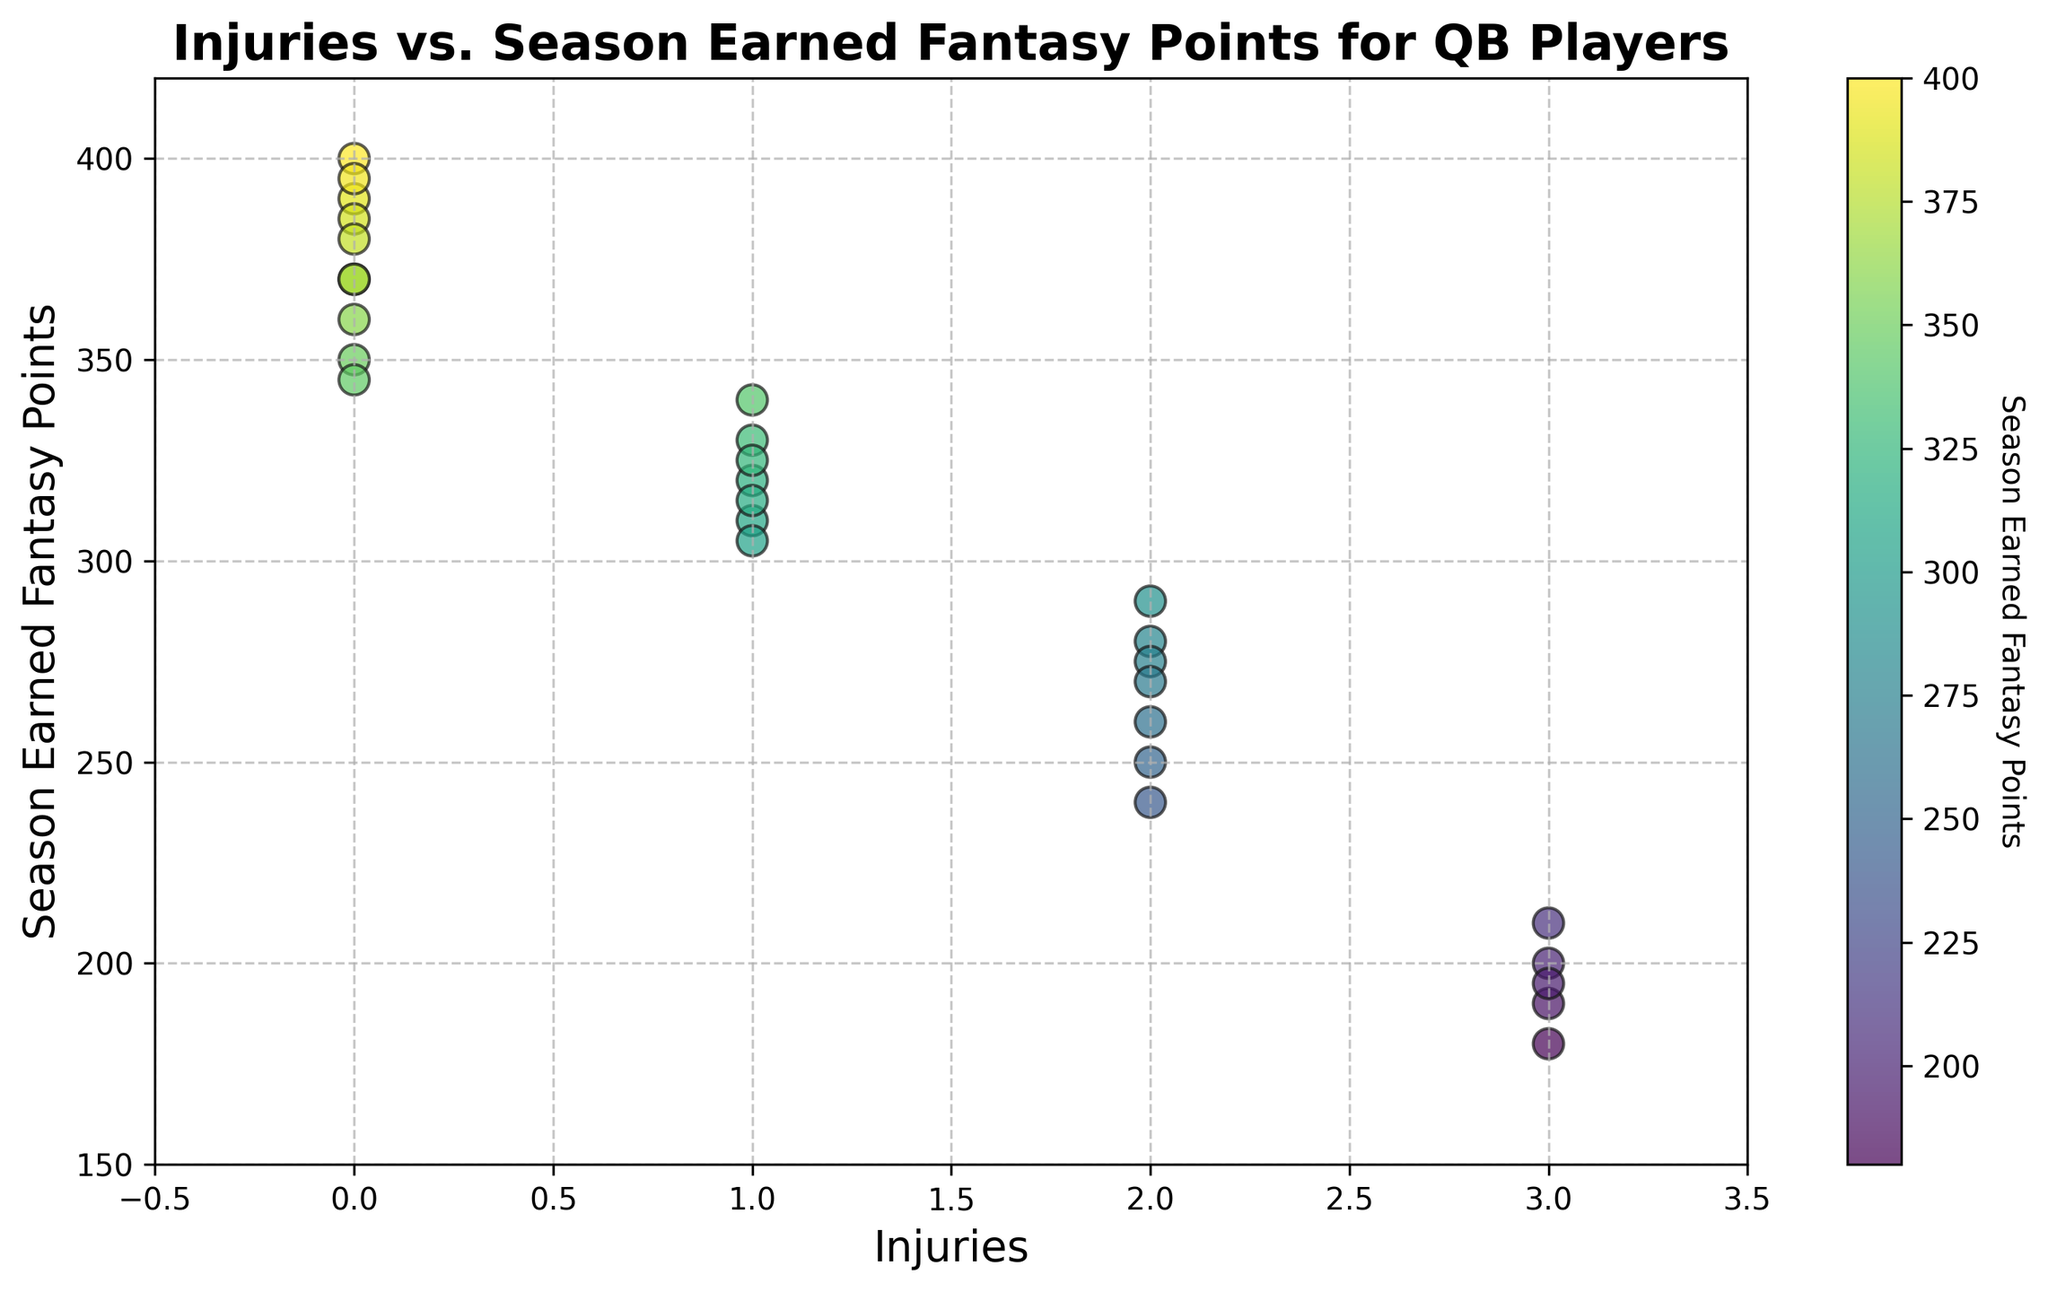How many players had zero injuries? To find the number of players with zero injuries, count the number of points on the x-axis at 0.
Answer: 8 Compare the range of fantasy points between players with different numbers of injuries. For each number of injuries (0, 1, 2, 3), find the minimum and maximum earned fantasy points. Players with 0 injuries: 345-400. Players with 1 injury: 305-340. Players with 2 injuries: 240-290. Players with 3 injuries: 180-210.
Answer: 0 injuries: 345-400, 1 injury: 305-340, 2 injuries: 240-290, 3 injuries: 180-210 Do players with no injuries generally score higher fantasy points than those with injuries? Compare the range of fantasy points for players with 0 injuries to those with 1, 2, and 3 injuries. Players with no injuries have a range from 345 to 400, while players with injuries have lower ranges: 305-340 (1 injury), 240-290 (2 injuries), 180-210 (3 injuries).
Answer: Yes What is the average fantasy points for players with 2 injuries? Sum the fantasy points for players with 2 injuries (280, 250, 260, 240, 275, 270, 290) and divide by the number of such players. (280 + 250 + 260 + 240 + 275 + 270 + 290) / 7 = 273.57
Answer: 273.57 How does the color intensity relate to the fantasy points scored? The color bar indicates that darker colors represent higher fantasy points, so points with higher fantasy scores will be darker on the plot.
Answer: Darker colors represent higher fantasy points Which injury category shows the most spread in fantasy points? Find the range (maximum - minimum) of fantasy points for each injury category. The spread for 0 injuries is 400-345=55, for 1 injury is 340-305=35, for 2 injuries is 290-240=50, and for 3 injuries is 210-180=30. The largest spread is for 0 injuries.
Answer: 0 injuries Identify the player group with the highest earned fantasy points. Look at the maximum value on the y-axis across all injuries. The highest point is at 400 fantasy points, which belongs to players with 0 injuries.
Answer: Players with 0 injuries Are there any outlier fantasy points for players with 3 injuries? Evaluate the points for players with 3 injuries. Points: 180, 190, 195, 200, 210. All values are within a close range and there don't appear to be outliers.
Answer: No What is the median fantasy points for players with 1 injury? List the fantasy points for players with 1 injury: (320, 340, 330, 310, 315, 305, 325). Order them: 305, 310, 315, 320, 325, 330, 340. The median value is the middle one, hence 320.
Answer: 320 